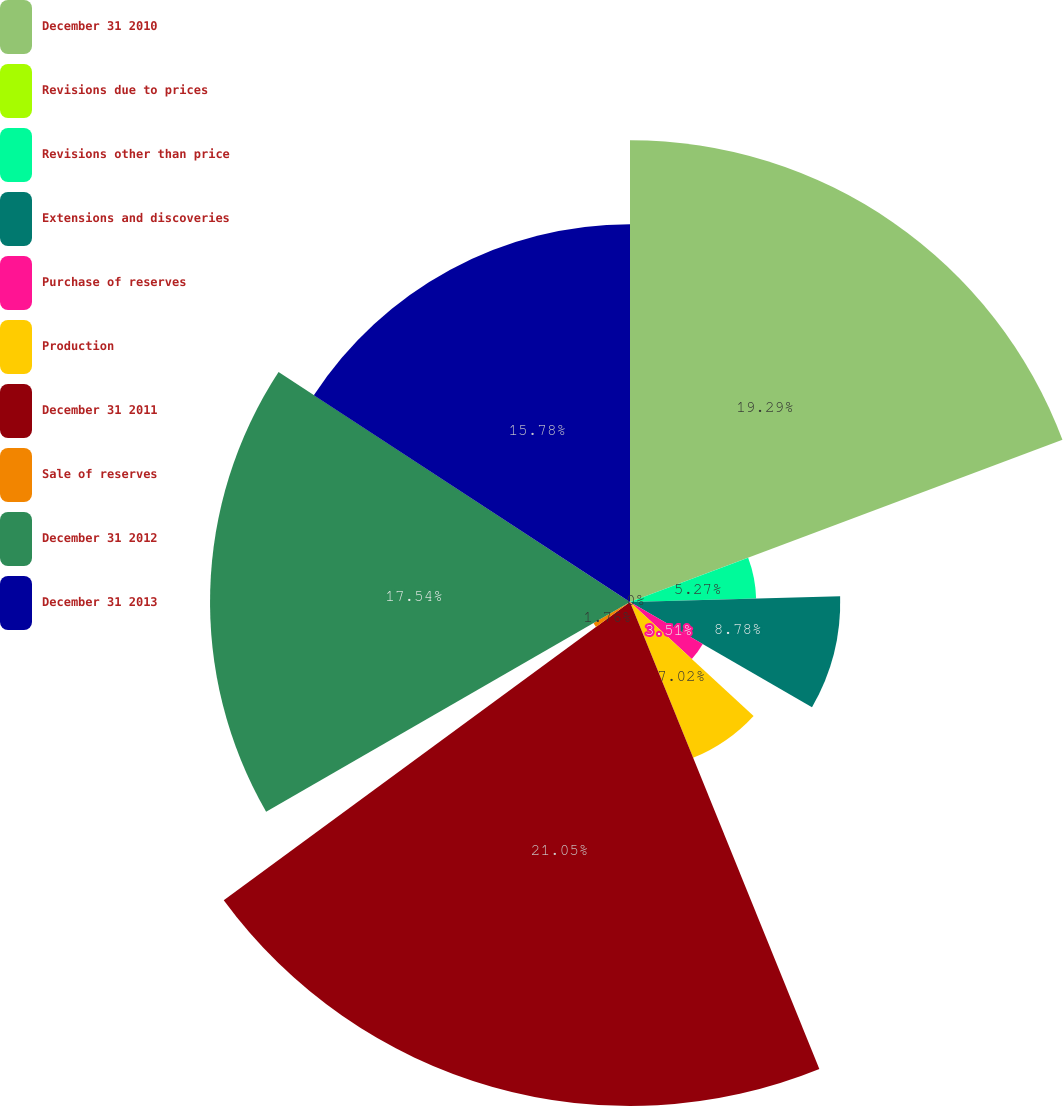Convert chart. <chart><loc_0><loc_0><loc_500><loc_500><pie_chart><fcel>December 31 2010<fcel>Revisions due to prices<fcel>Revisions other than price<fcel>Extensions and discoveries<fcel>Purchase of reserves<fcel>Production<fcel>December 31 2011<fcel>Sale of reserves<fcel>December 31 2012<fcel>December 31 2013<nl><fcel>19.29%<fcel>0.0%<fcel>5.27%<fcel>8.78%<fcel>3.51%<fcel>7.02%<fcel>21.05%<fcel>1.76%<fcel>17.54%<fcel>15.78%<nl></chart> 